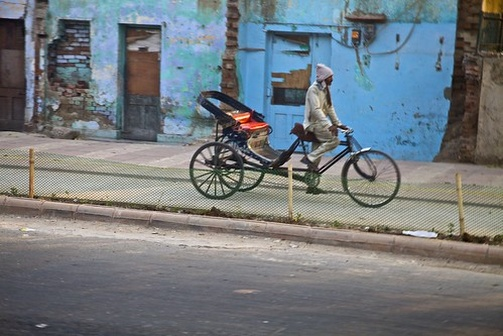What might the man be doing on the tricycle? The man might be using the tricycle for various purposes such as transporting goods, commuting to work, or running errands around the city. The large basket on the tricycle suggests it is designed for carrying items, which could be groceries, personal belongings, or goods for delivery. 